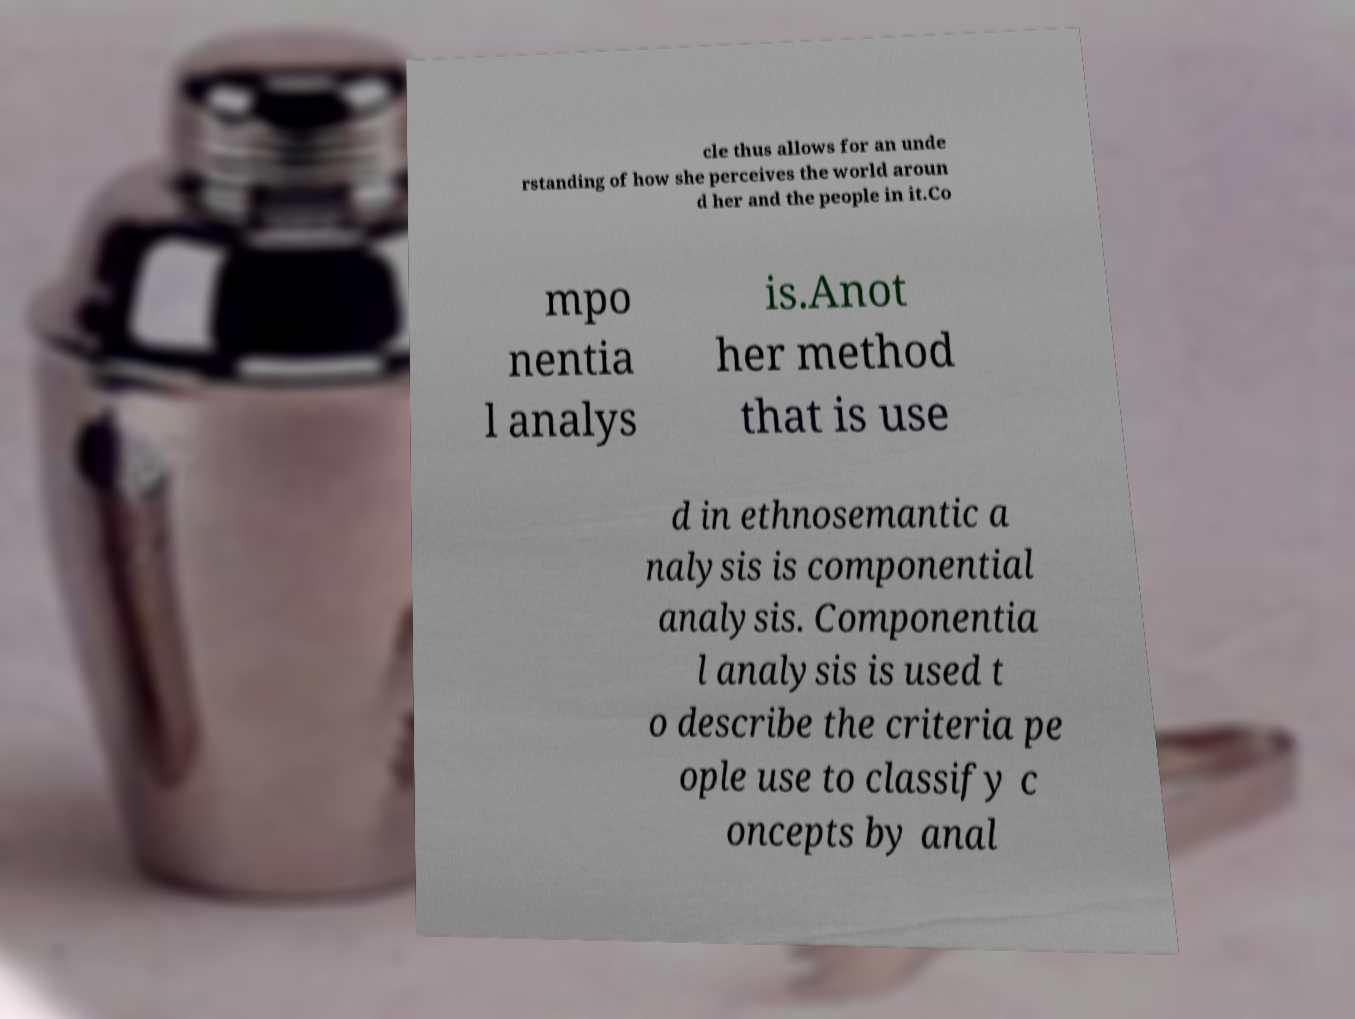There's text embedded in this image that I need extracted. Can you transcribe it verbatim? cle thus allows for an unde rstanding of how she perceives the world aroun d her and the people in it.Co mpo nentia l analys is.Anot her method that is use d in ethnosemantic a nalysis is componential analysis. Componentia l analysis is used t o describe the criteria pe ople use to classify c oncepts by anal 